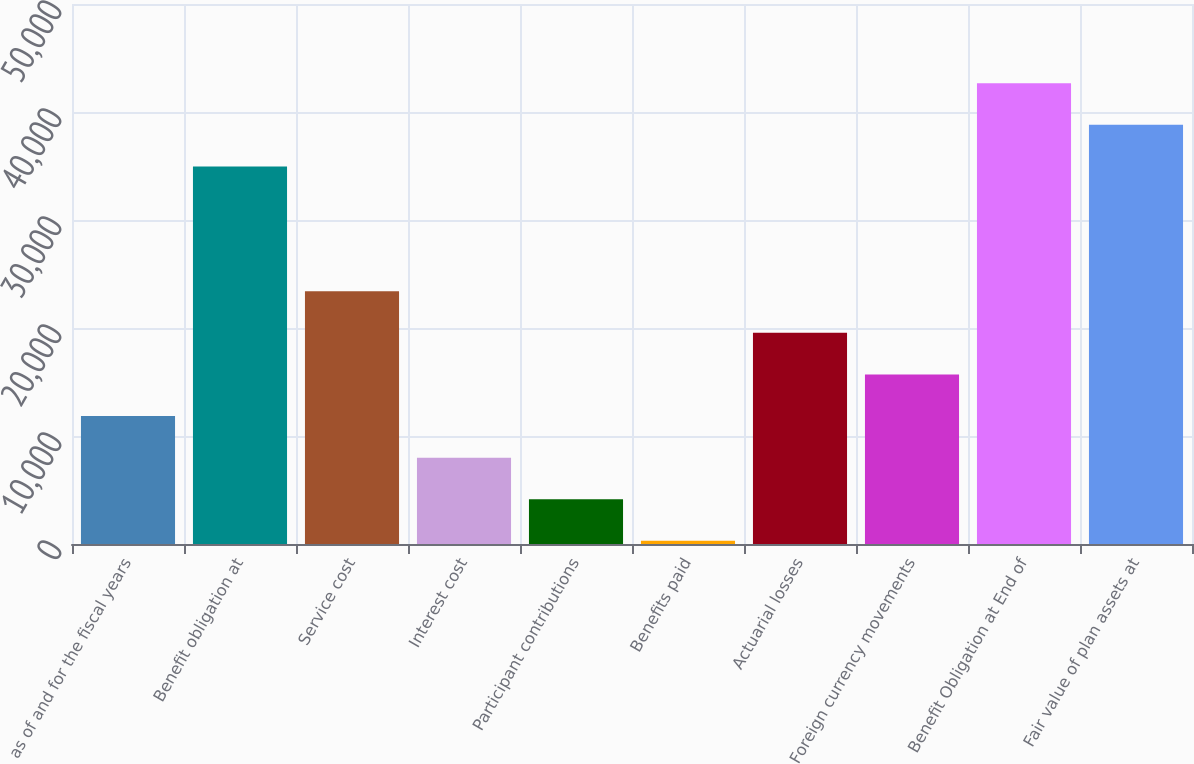Convert chart to OTSL. <chart><loc_0><loc_0><loc_500><loc_500><bar_chart><fcel>as of and for the fiscal years<fcel>Benefit obligation at<fcel>Service cost<fcel>Interest cost<fcel>Participant contributions<fcel>Benefits paid<fcel>Actuarial losses<fcel>Foreign currency movements<fcel>Benefit Obligation at End of<fcel>Fair value of plan assets at<nl><fcel>11848.1<fcel>34958.3<fcel>23403.2<fcel>7996.4<fcel>4144.7<fcel>293<fcel>19551.5<fcel>15699.8<fcel>42661.7<fcel>38810<nl></chart> 